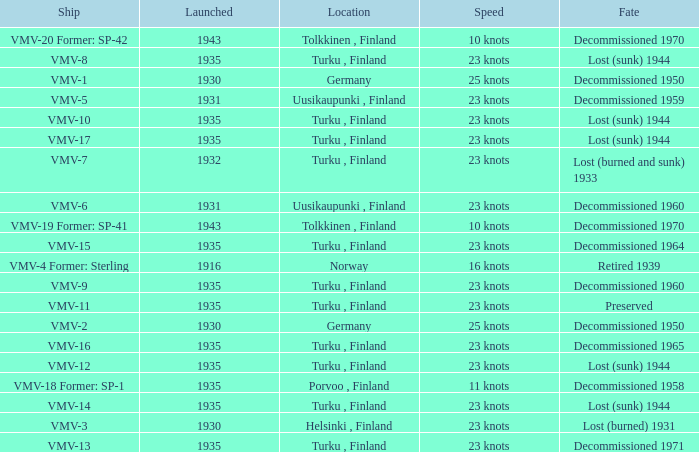What is the average launch date of the vmv-1 vessel in Germany? 1930.0. 